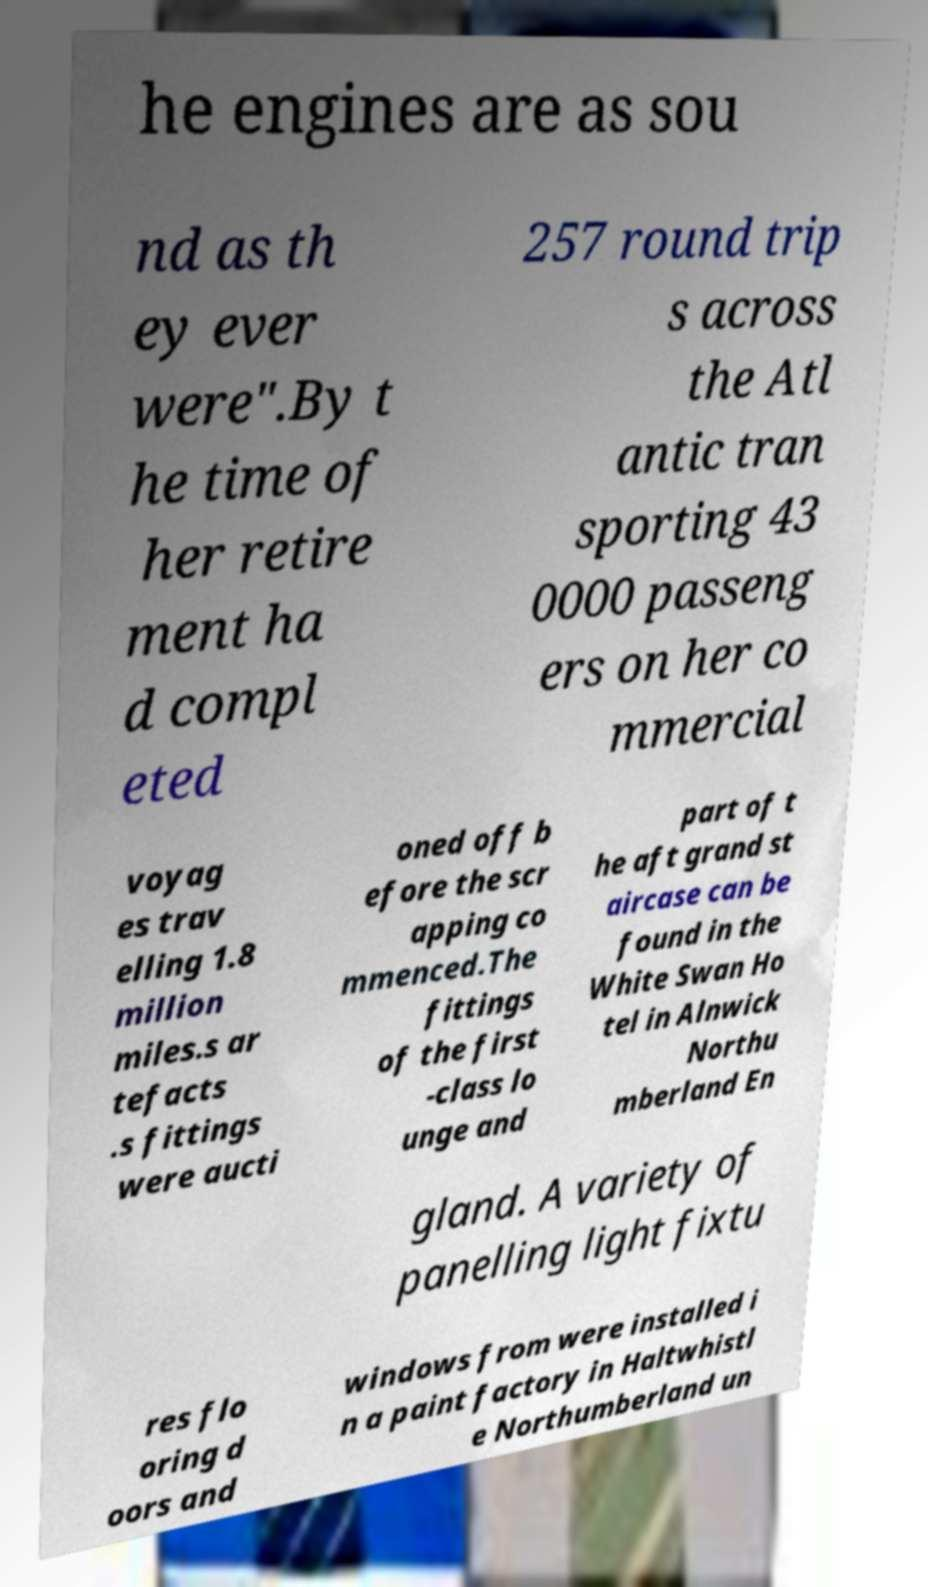Could you extract and type out the text from this image? he engines are as sou nd as th ey ever were".By t he time of her retire ment ha d compl eted 257 round trip s across the Atl antic tran sporting 43 0000 passeng ers on her co mmercial voyag es trav elling 1.8 million miles.s ar tefacts .s fittings were aucti oned off b efore the scr apping co mmenced.The fittings of the first -class lo unge and part of t he aft grand st aircase can be found in the White Swan Ho tel in Alnwick Northu mberland En gland. A variety of panelling light fixtu res flo oring d oors and windows from were installed i n a paint factory in Haltwhistl e Northumberland un 